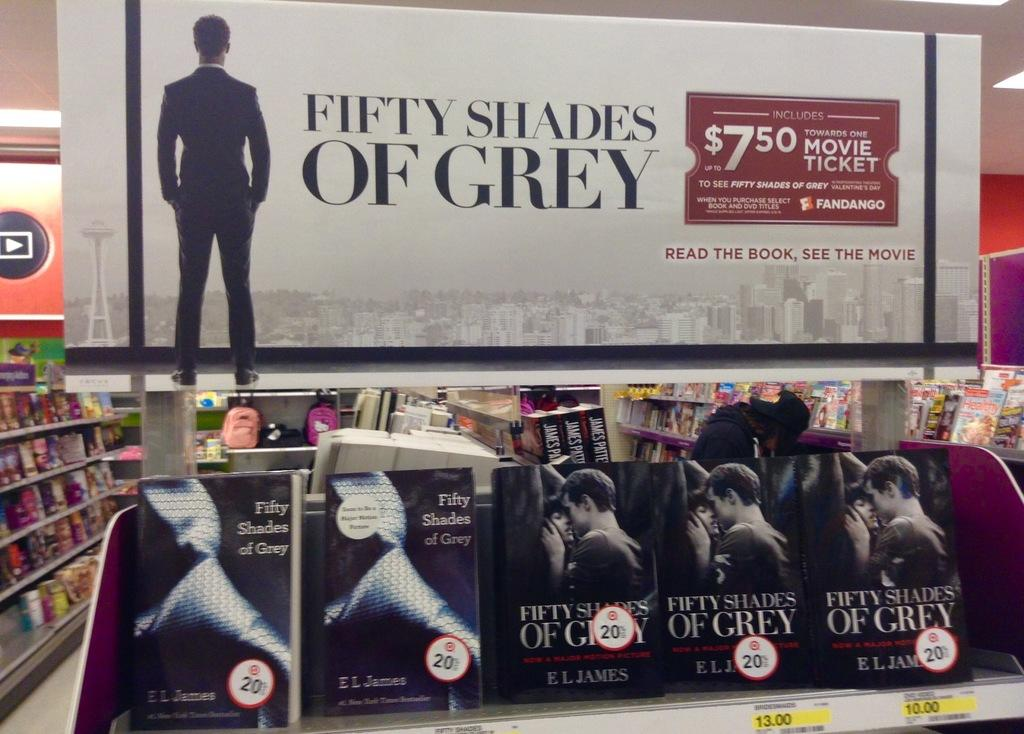<image>
Offer a succinct explanation of the picture presented. A sign advertising Fifty Shades of Grey is above shelving in a book store. 